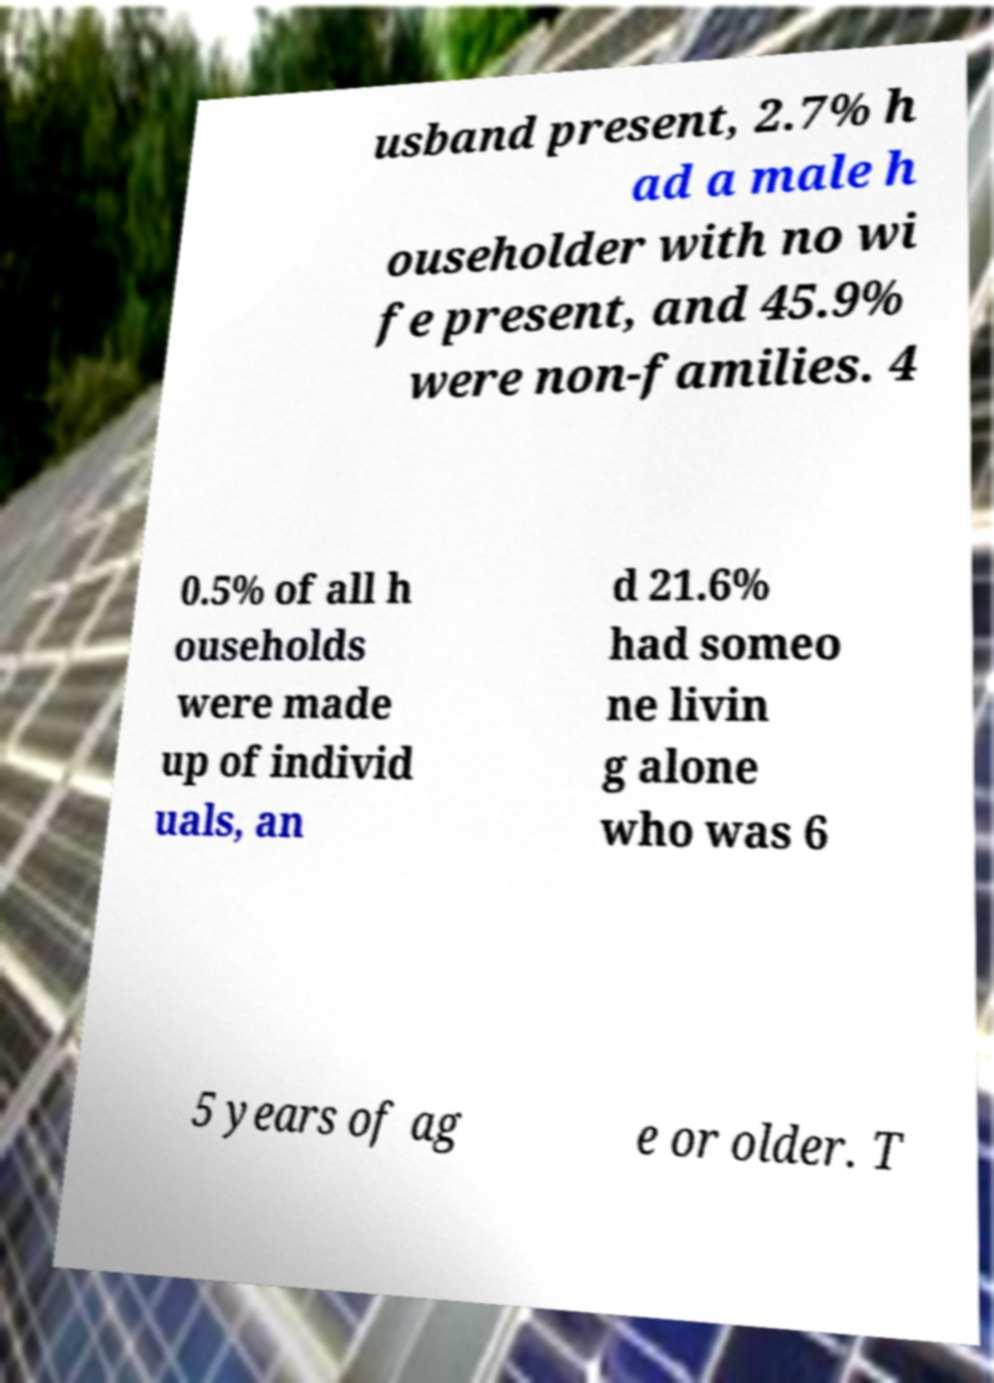Can you read and provide the text displayed in the image?This photo seems to have some interesting text. Can you extract and type it out for me? usband present, 2.7% h ad a male h ouseholder with no wi fe present, and 45.9% were non-families. 4 0.5% of all h ouseholds were made up of individ uals, an d 21.6% had someo ne livin g alone who was 6 5 years of ag e or older. T 